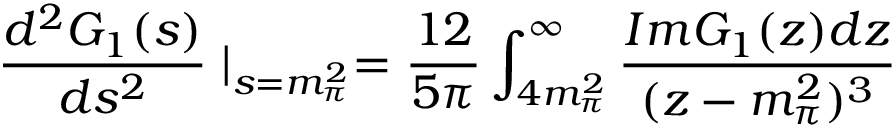Convert formula to latex. <formula><loc_0><loc_0><loc_500><loc_500>\frac { d ^ { 2 } G _ { 1 } ( s ) } { d s ^ { 2 } } | _ { s = m _ { \pi } ^ { 2 } } = \frac { 1 2 } { 5 \pi } \int _ { 4 m _ { \pi } ^ { 2 } } ^ { \infty } \frac { I m G _ { 1 } ( z ) d z } { ( z - m _ { \pi } ^ { 2 } ) ^ { 3 } }</formula> 